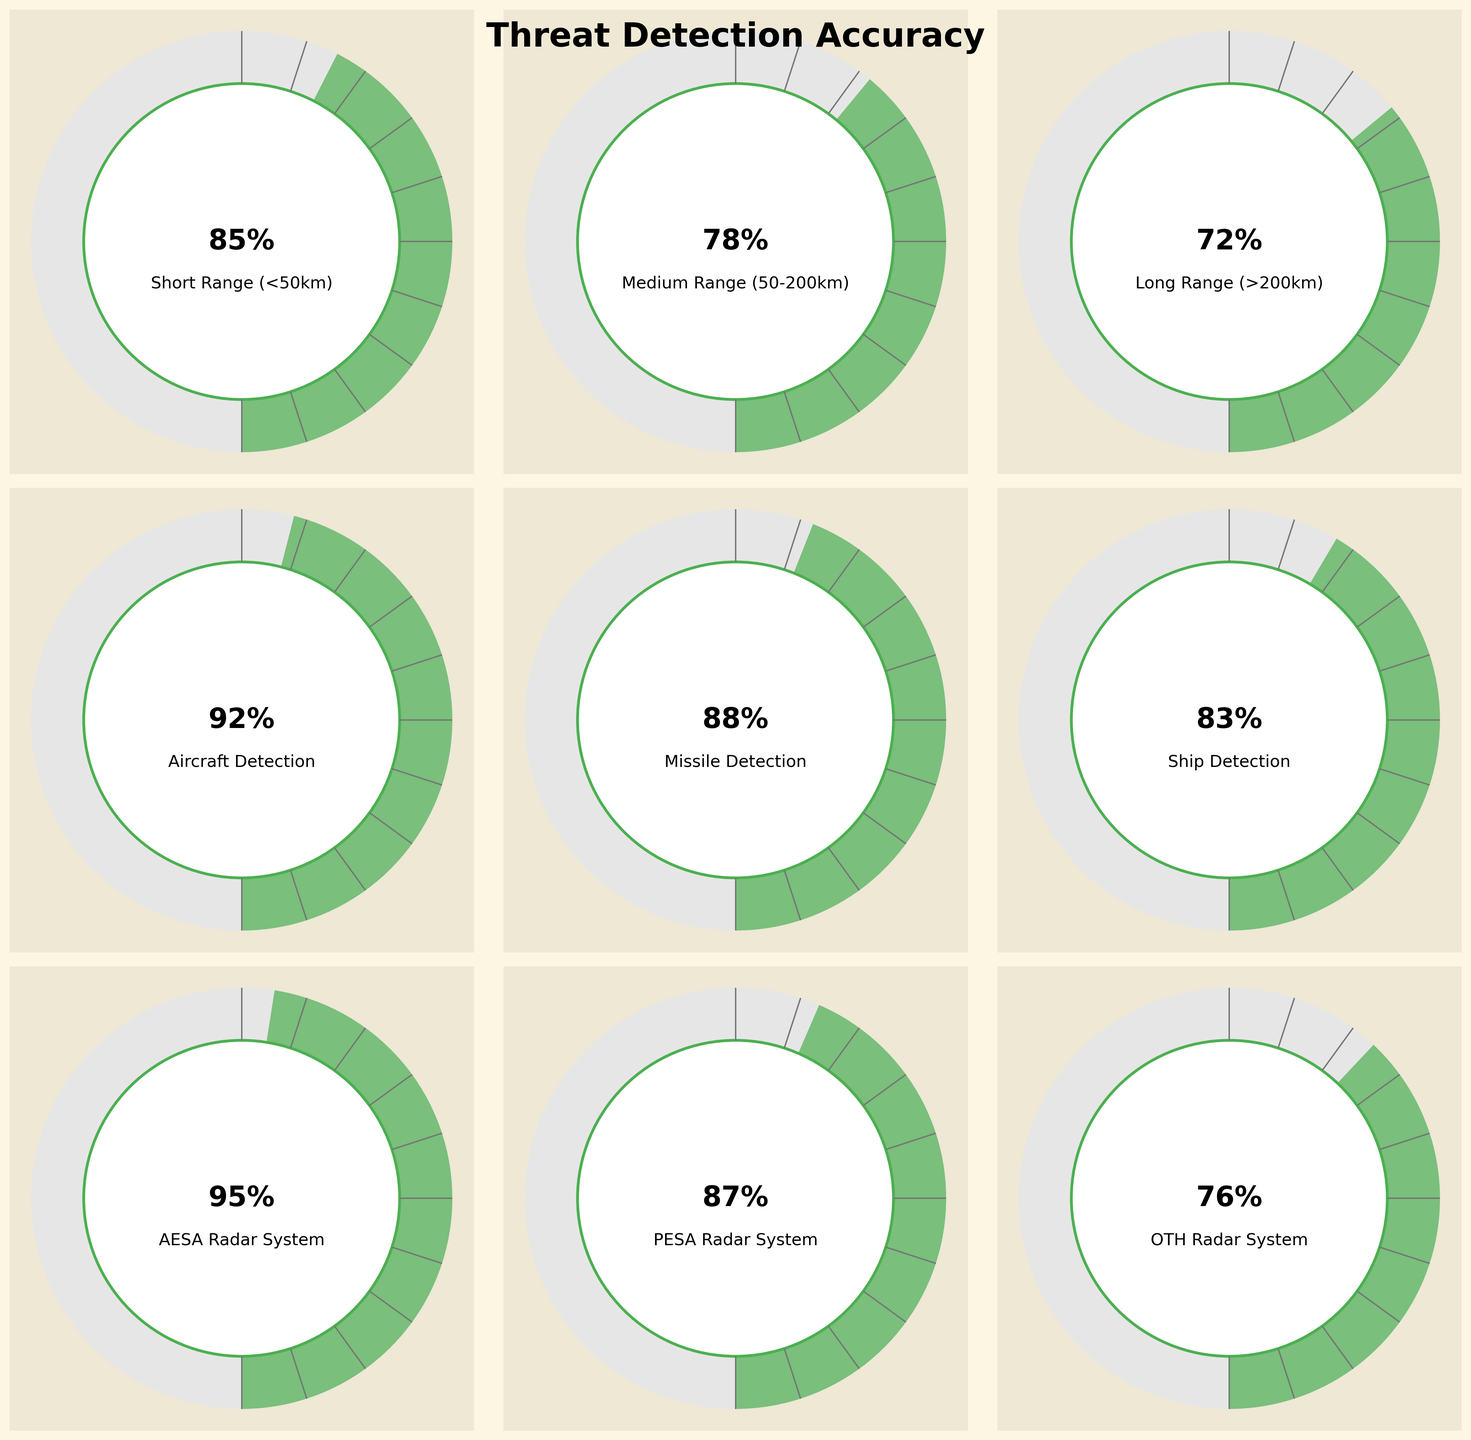What is the accuracy of the AESA Radar System? Looking at the gauge chart labeled "AESA Radar System," the percentage value displayed is 95%.
Answer: 95% Which radar system has the lowest accuracy? By comparing the percentage values in each radar system's gauge chart, the "OTH Radar System" shows the lowest value at 76%.
Answer: OTH Radar System Between short-range and long-range detection, which one has a higher accuracy? Referring to the gauge charts, "Short Range (<50km)" has an accuracy of 85%, whereas "Long Range (>200km)" has an accuracy of 72%. Thus, short-range detection has a higher accuracy.
Answer: Short Range (<50km) What is the difference in accuracy between missile detection and ship detection? The accuracy of missile detection is 88%, and the accuracy of ship detection is 83%. The difference is 88% - 83% = 5%.
Answer: 5% Which target-type detection has the highest accuracy? Analyzing the target type gauge charts for "Aircraft Detection," "Missile Detection," and "Ship Detection," the highest percentage value is for "Aircraft Detection" at 92%.
Answer: Aircraft Detection How does the accuracy of the PESA Radar System compare to that of the Medium Range (50-200km)? The PESA Radar System has an accuracy of 87%, while the Medium Range detection has an accuracy of 78%. The PESA Radar System has a higher accuracy.
Answer: PESA Radar System What is the average accuracy of all the radar systems combined? Summing up the accuracy values of AESA (95%), PESA (87%), and OTH (76%) and then dividing by the number of systems (3) gives (95 + 87 + 76) / 3 = 86%.
Answer: 86% If you were to prioritize a single radar system based on highest accuracy, which one would it be? Comparing the accuracies of all radar systems, the AESA Radar System has the highest accuracy at 95%.
Answer: AESA Radar System Does aircraft detection have a better accuracy than short-range detection? The gauge for "Aircraft Detection" shows an accuracy of 92%, whereas "Short Range (<50km)" shows an accuracy of 85%. Therefore, aircraft detection has better accuracy.
Answer: Yes 